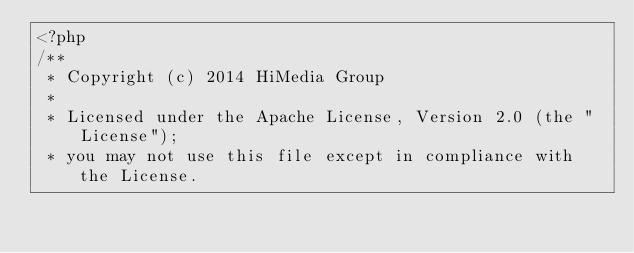Convert code to text. <code><loc_0><loc_0><loc_500><loc_500><_PHP_><?php
/**
 * Copyright (c) 2014 HiMedia Group
 *
 * Licensed under the Apache License, Version 2.0 (the "License");
 * you may not use this file except in compliance with the License.</code> 